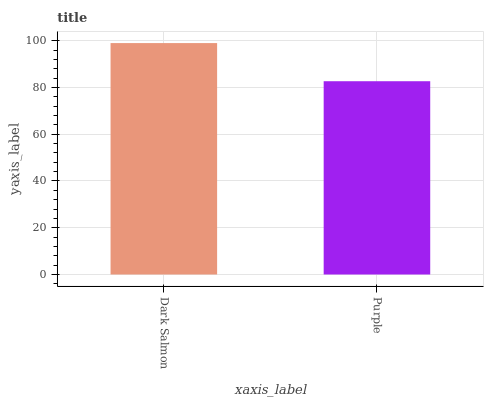Is Purple the minimum?
Answer yes or no. Yes. Is Dark Salmon the maximum?
Answer yes or no. Yes. Is Purple the maximum?
Answer yes or no. No. Is Dark Salmon greater than Purple?
Answer yes or no. Yes. Is Purple less than Dark Salmon?
Answer yes or no. Yes. Is Purple greater than Dark Salmon?
Answer yes or no. No. Is Dark Salmon less than Purple?
Answer yes or no. No. Is Dark Salmon the high median?
Answer yes or no. Yes. Is Purple the low median?
Answer yes or no. Yes. Is Purple the high median?
Answer yes or no. No. Is Dark Salmon the low median?
Answer yes or no. No. 